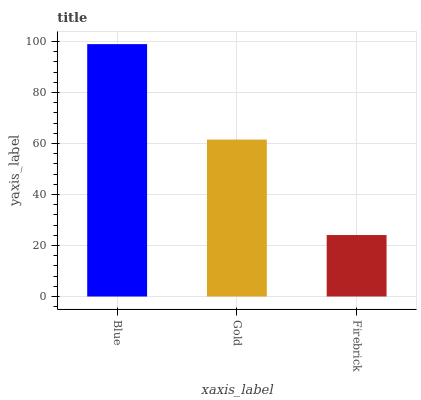Is Firebrick the minimum?
Answer yes or no. Yes. Is Blue the maximum?
Answer yes or no. Yes. Is Gold the minimum?
Answer yes or no. No. Is Gold the maximum?
Answer yes or no. No. Is Blue greater than Gold?
Answer yes or no. Yes. Is Gold less than Blue?
Answer yes or no. Yes. Is Gold greater than Blue?
Answer yes or no. No. Is Blue less than Gold?
Answer yes or no. No. Is Gold the high median?
Answer yes or no. Yes. Is Gold the low median?
Answer yes or no. Yes. Is Blue the high median?
Answer yes or no. No. Is Blue the low median?
Answer yes or no. No. 